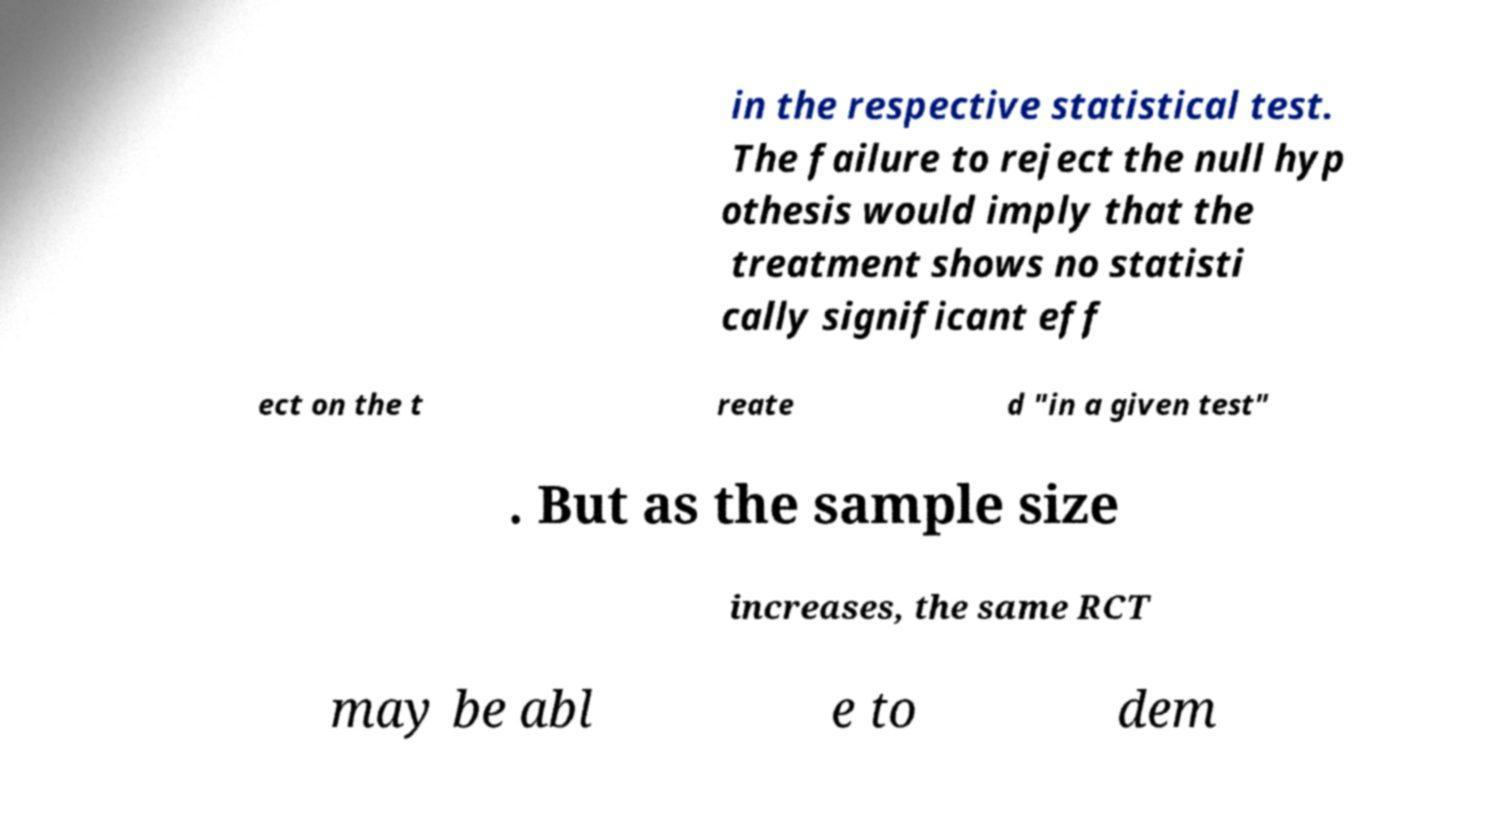For documentation purposes, I need the text within this image transcribed. Could you provide that? in the respective statistical test. The failure to reject the null hyp othesis would imply that the treatment shows no statisti cally significant eff ect on the t reate d "in a given test" . But as the sample size increases, the same RCT may be abl e to dem 